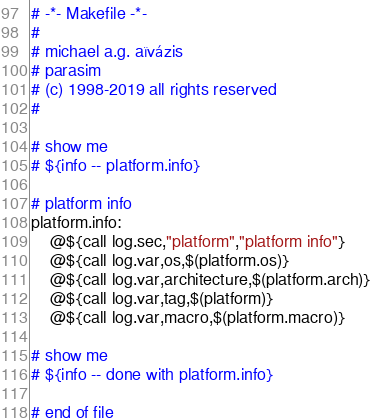Convert code to text. <code><loc_0><loc_0><loc_500><loc_500><_ObjectiveC_># -*- Makefile -*-
#
# michael a.g. aïvázis
# parasim
# (c) 1998-2019 all rights reserved
#

# show me
# ${info -- platform.info}

# platform info
platform.info:
	@${call log.sec,"platform","platform info"}
	@${call log.var,os,$(platform.os)}
	@${call log.var,architecture,$(platform.arch)}
	@${call log.var,tag,$(platform)}
	@${call log.var,macro,$(platform.macro)}

# show me
# ${info -- done with platform.info}

# end of file
</code> 